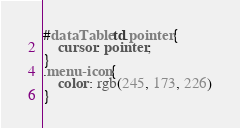Convert code to text. <code><loc_0><loc_0><loc_500><loc_500><_CSS_>#dataTable td.pointer{
    cursor: pointer;
}
.menu-icon{
    color: rgb(245, 173, 226)
}</code> 